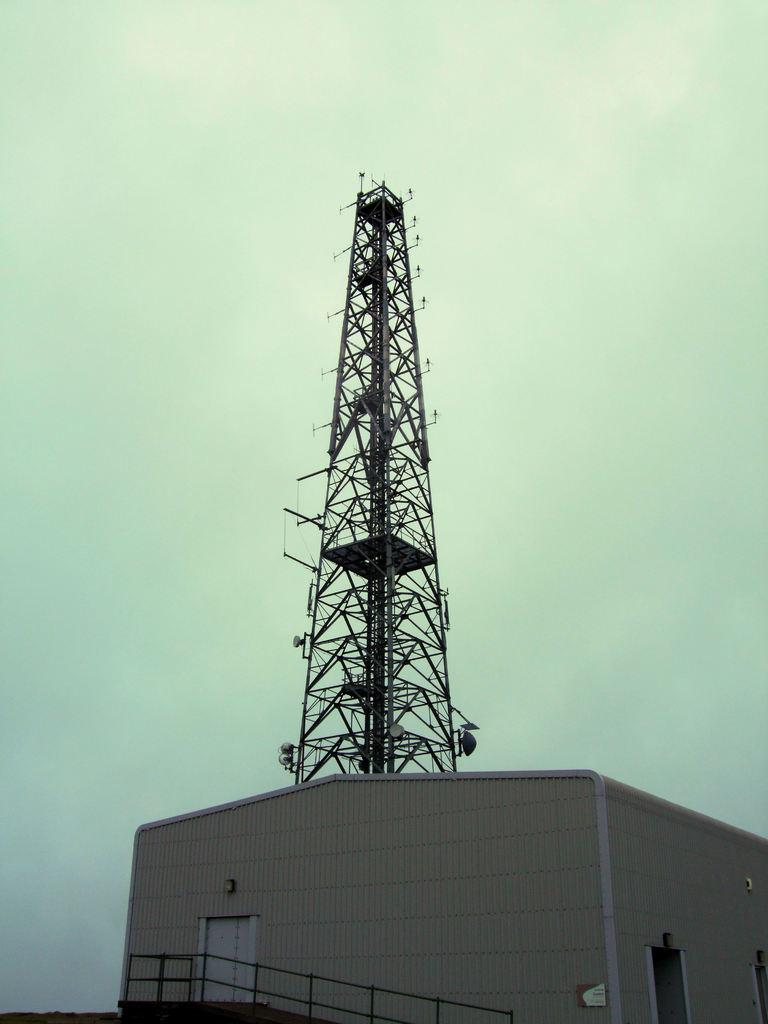What type of structure is present in the image? There is a building in the image. What feature can be seen near the building? There is a railing in the image. What other architectural element is visible in the image? There is a tower in the image. What can be seen in the distance in the image? The sky is visible in the background of the image. What type of zephyr can be seen blowing through the building in the image? There is no zephyr present in the image, as a zephyr refers to a gentle breeze, and there is no indication of wind in the image. 